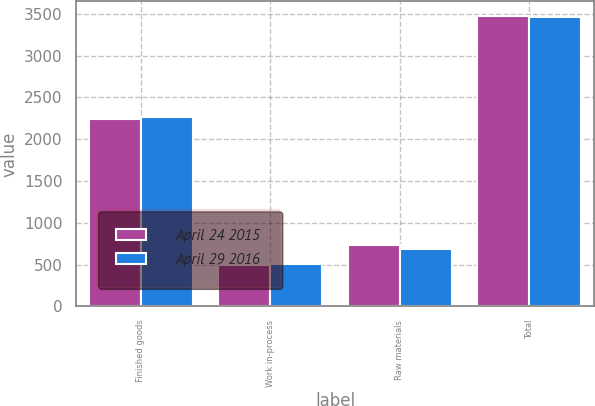<chart> <loc_0><loc_0><loc_500><loc_500><stacked_bar_chart><ecel><fcel>Finished goods<fcel>Work in-process<fcel>Raw materials<fcel>Total<nl><fcel>April 24 2015<fcel>2242<fcel>499<fcel>732<fcel>3473<nl><fcel>April 29 2016<fcel>2268<fcel>509<fcel>686<fcel>3463<nl></chart> 